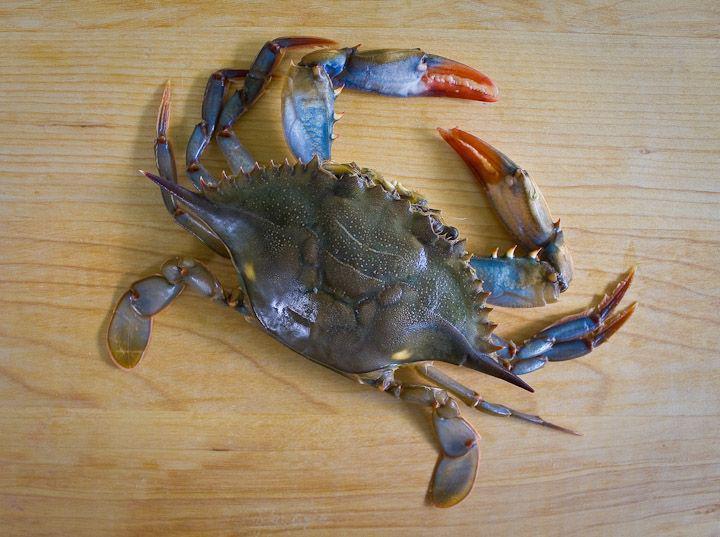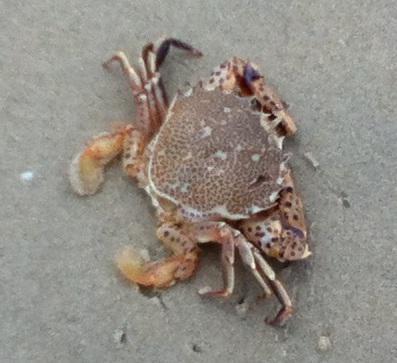The first image is the image on the left, the second image is the image on the right. Examine the images to the left and right. Is the description "Each image is a top-view of a crab with its face positioned at the bottom, and the crab on the left is more purplish and with black-tipped front claws, while the crab on the right is grayer." accurate? Answer yes or no. No. 